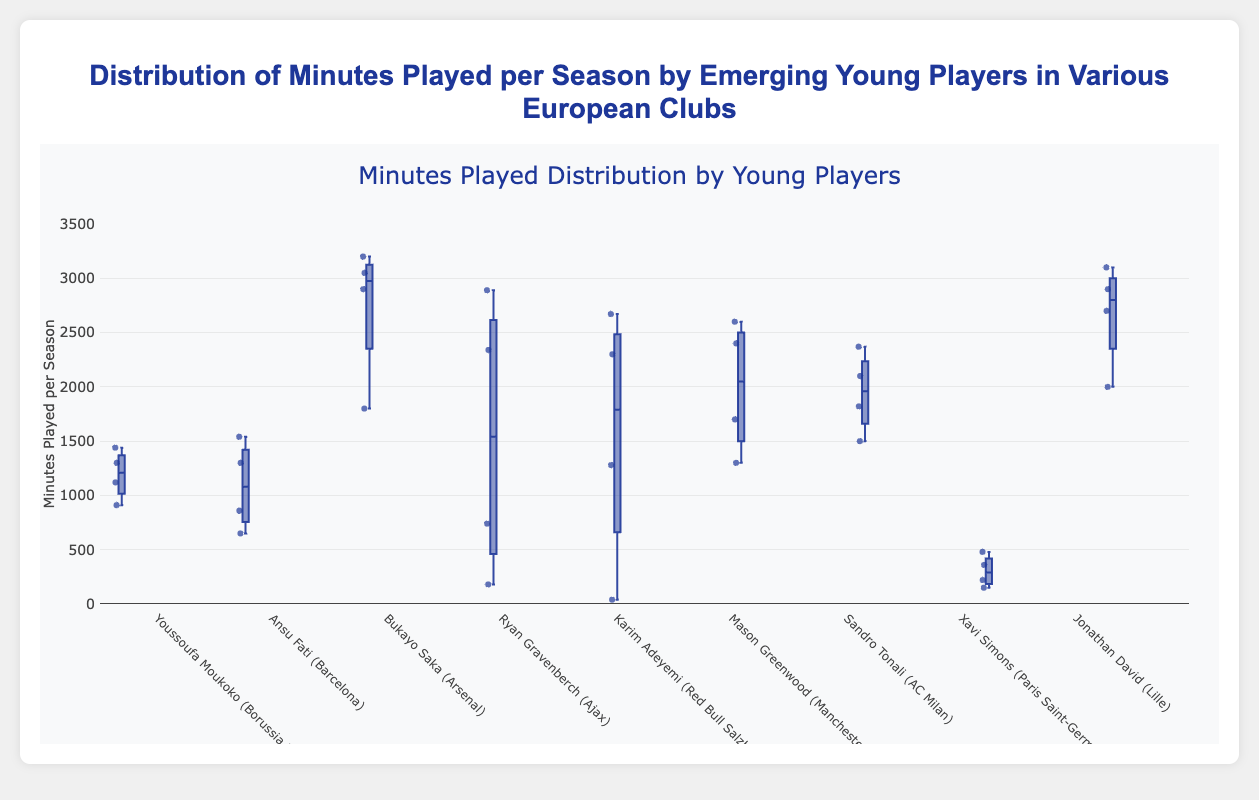How many minutes did Youssoufa Moukoko play in the maximum season? Look at the box plot for Youssoufa Moukoko, locate the highest data point in the vertical line which represents the maximum value.
Answer: 1440 What is the median value for Bukayo Saka's minutes played per season? Identify Bukayo Saka’s box plot. The line inside the box represents the median value.
Answer: 3050 Which player has the lowest minimum value for minutes played in a season? Examine the data points for each player's box plot. The lowest point in the vertical line indicates the minimum value. Karim Adeyemi’s box plot has a minimum value of 40 which is the lowest among all players.
Answer: Karim Adeyemi Compare the interquartile range (IQR) of Sandro Tonali and Ansu Fati. Determine the range between the lower quartile (Q1) and the upper quartile (Q3) for both players' box plots. Q1 to Q3 for Ansu Fati is 860 to 1540 (680), and for Sandro Tonali, it is 1820 to 2370 (550).
Answer: Sandro Tonali’s IQR is less than Ansu Fati’s Which player's minutes displayed the greatest variation (consider the spread of the box plot)? Look for the box plot with the widest spread between the whiskers (minimum to maximum) and also the widest box indicating high variability. Bukayo Saka’s box plot shows the greatest variation.
Answer: Bukayo Saka What is the median of Ryan Gravenberch’s minutes played? Identify Ryan Gravenberch’s box plot from Ajax. The median is indicated by the line inside his box plot.
Answer: 2340 Between Jonathan David and Mason Greenwood, which player has a greater median? Compare the medians indicated by the lines inside the boxes of Jonathan David and Mason Greenwood.
Answer: Jonathan David Which player's minutes played tend to have the lowest values overall? Look for the lowest points in the vertical lines which represent the minimum values. Xavi Simons’ box plot shows that his values are generally the lowest.
Answer: Xavi Simons What is the median of Karim Adeyemi’s minutes played per season? Locate Karim Adeyemi's box plot and find the line inside the box which represents the median value.
Answer: 2300 